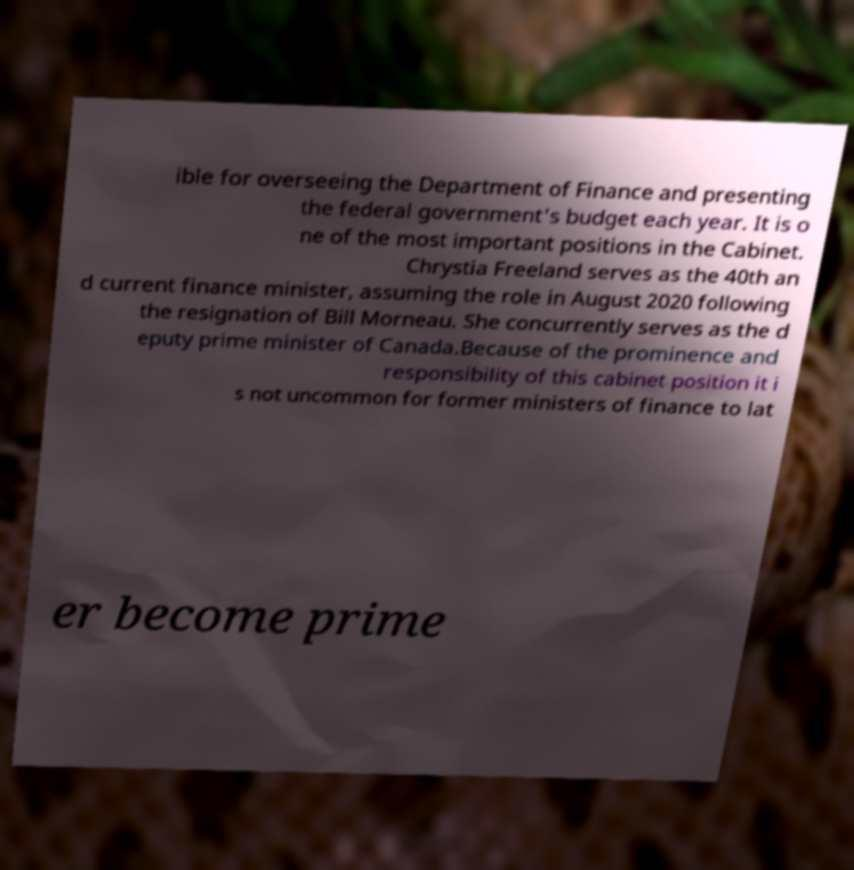Can you accurately transcribe the text from the provided image for me? ible for overseeing the Department of Finance and presenting the federal government's budget each year. It is o ne of the most important positions in the Cabinet. Chrystia Freeland serves as the 40th an d current finance minister, assuming the role in August 2020 following the resignation of Bill Morneau. She concurrently serves as the d eputy prime minister of Canada.Because of the prominence and responsibility of this cabinet position it i s not uncommon for former ministers of finance to lat er become prime 